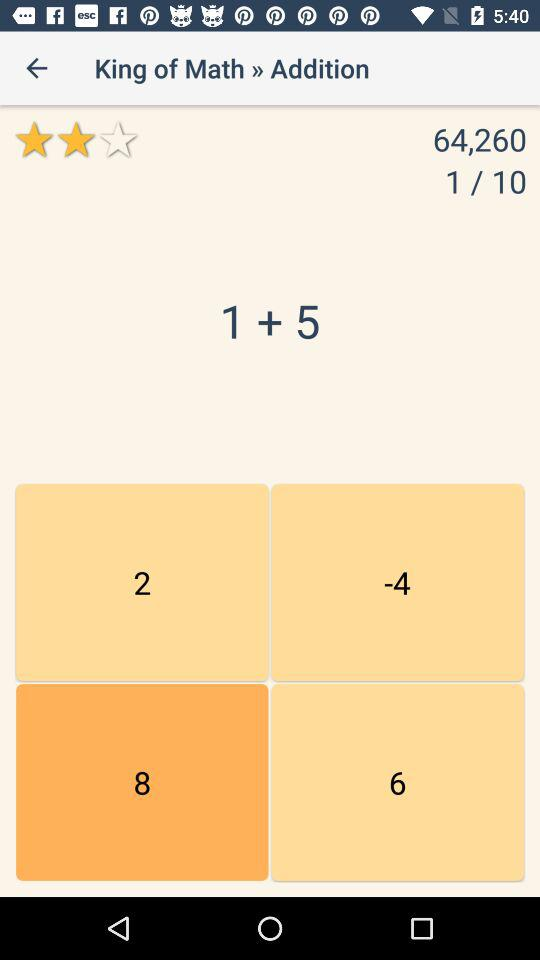What is the rating? The rating is 2 stars. 